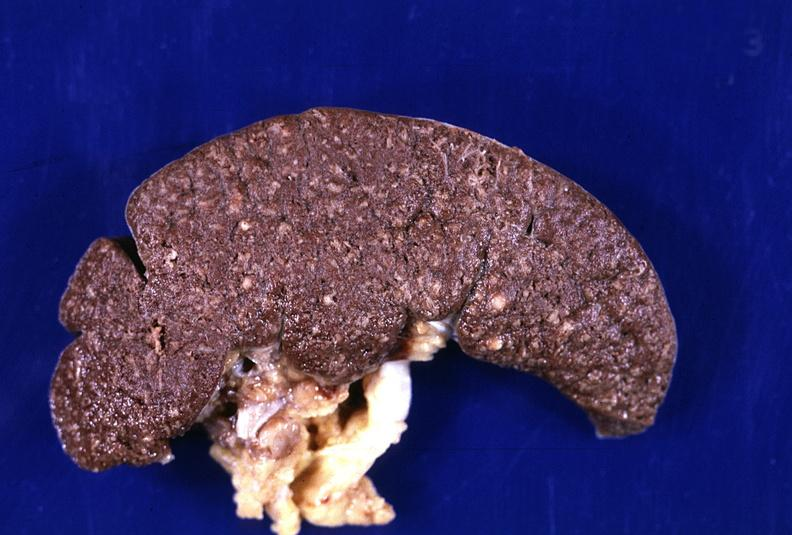where is this part in?
Answer the question using a single word or phrase. Spleen 